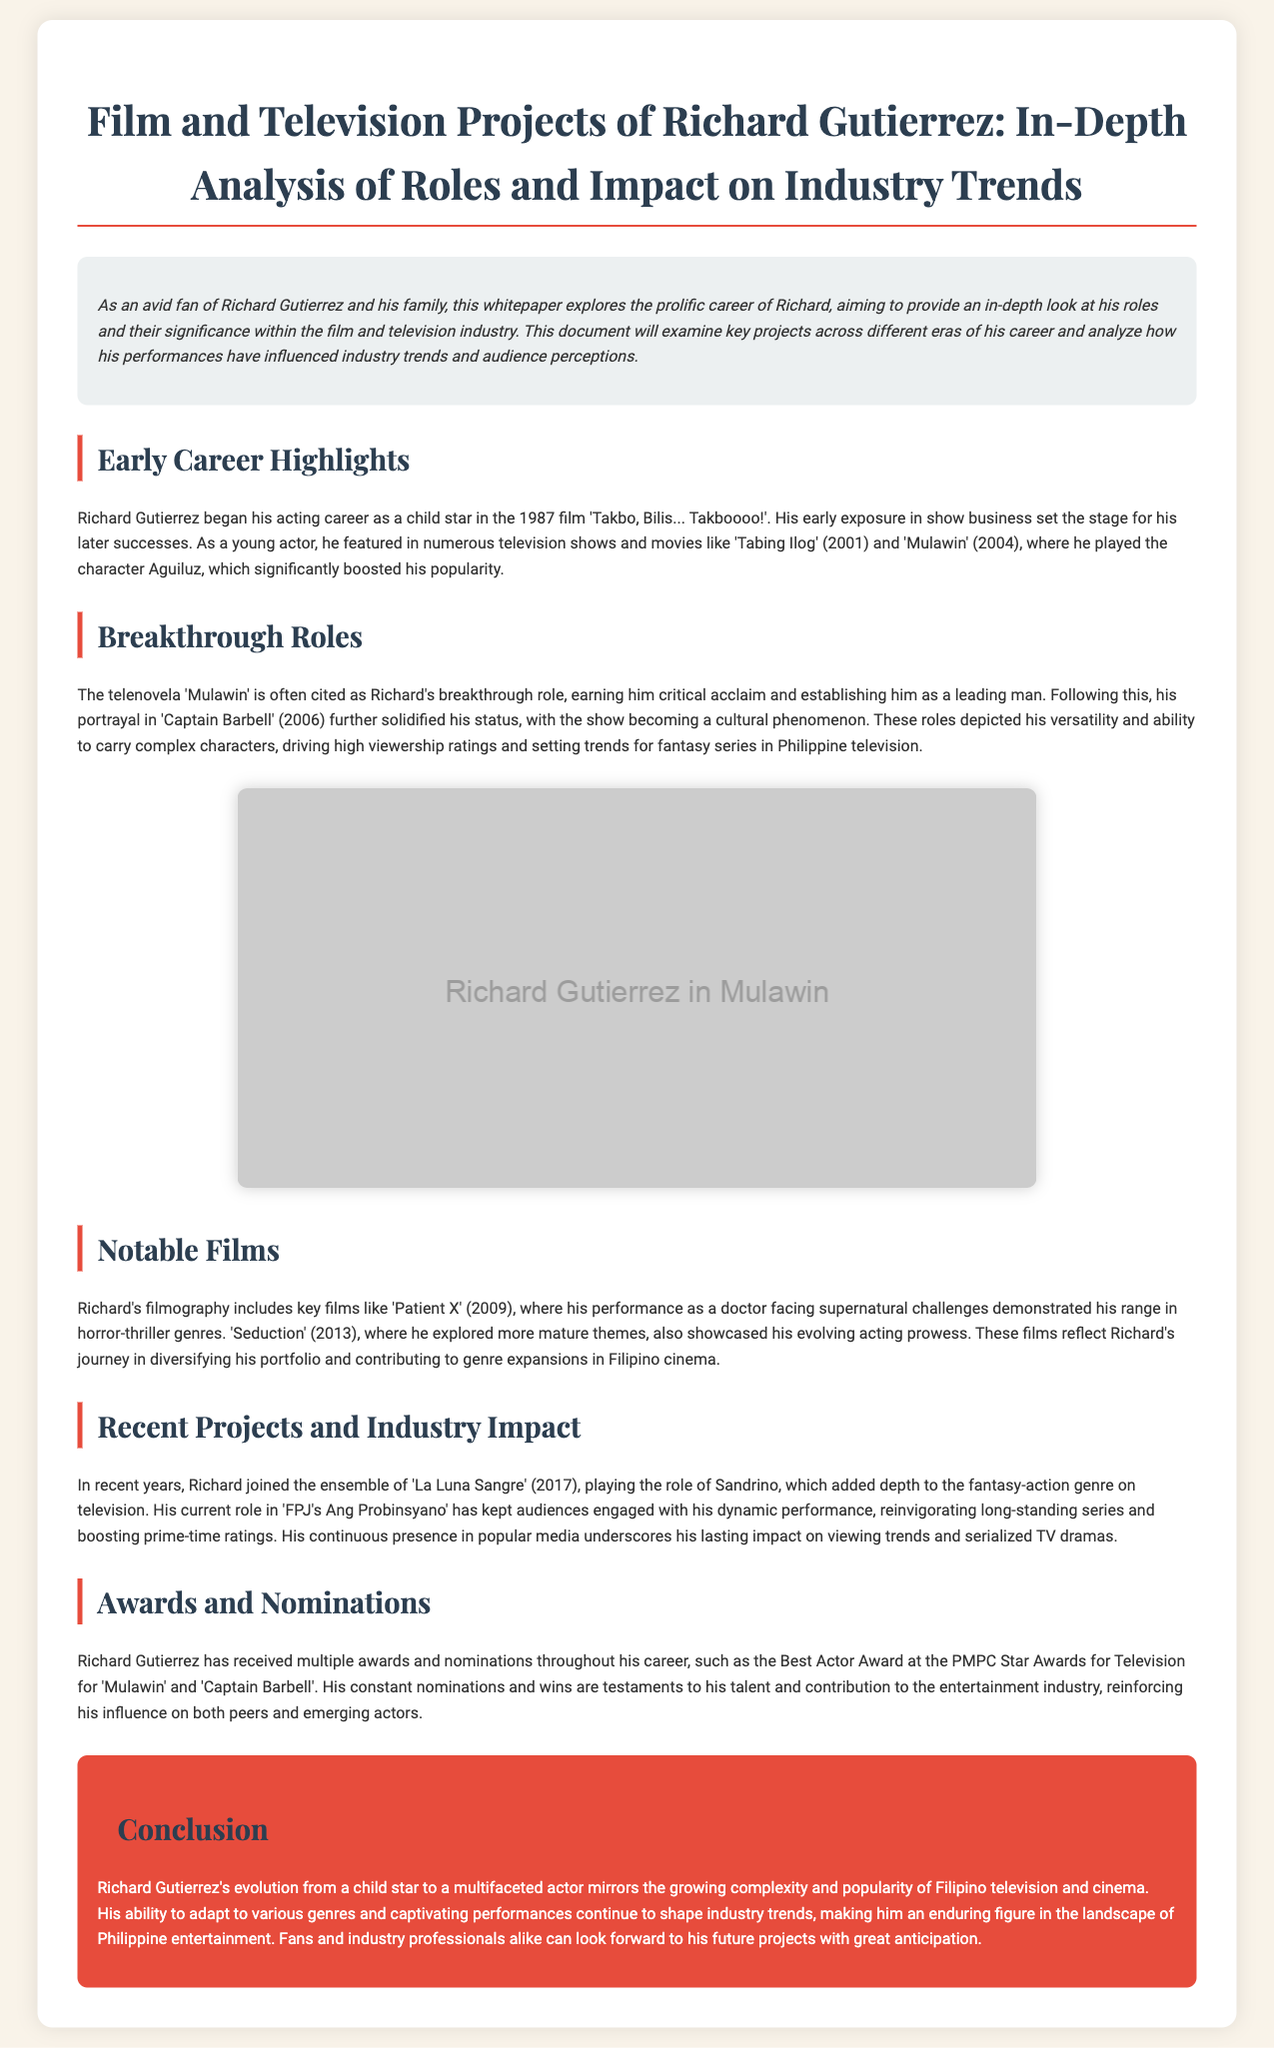what was Richard Gutierrez's first film? The document states Richard Gutierrez began his acting career with the film 'Takbo, Bilis... Takboooo!'.
Answer: 'Takbo, Bilis... Takboooo!' which character significantly boosted Richard's popularity? According to the document, Richard Gutierrez played the character Aguiluz in 'Mulawin', which significantly boosted his popularity.
Answer: Aguiluz what year did Richard Gutierrez appear in 'Captain Barbell'? The document mentions that Richard Gutierrez's role in 'Captain Barbell' was in 2006.
Answer: 2006 what genre does the film 'Patient X' belong to? The document describes 'Patient X' (2009) as a horror-thriller film.
Answer: horror-thriller which recent project features Richard in a role named Sandrino? The document states that Richard joined the ensemble of 'La Luna Sangre' as Sandrino in 2017.
Answer: La Luna Sangre how many awards did Richard Gutierrez receive at the PMPC Star Awards for Television? The document indicates that Richard received the Best Actor Award at the PMPC Star Awards for Television, but does not specify how many awards overall.
Answer: Not specified what is the main theme of the document? The document analyzes Richard Gutierrez's roles and their significance within the film and television industry.
Answer: Analysis of roles and significance how does Richard's career reflect trends in the Philippine entertainment industry? The document describes Richard Gutierrez's evolution from a child star to a multifaceted actor, influencing trends within the industry.
Answer: Evolution and influence on trends 